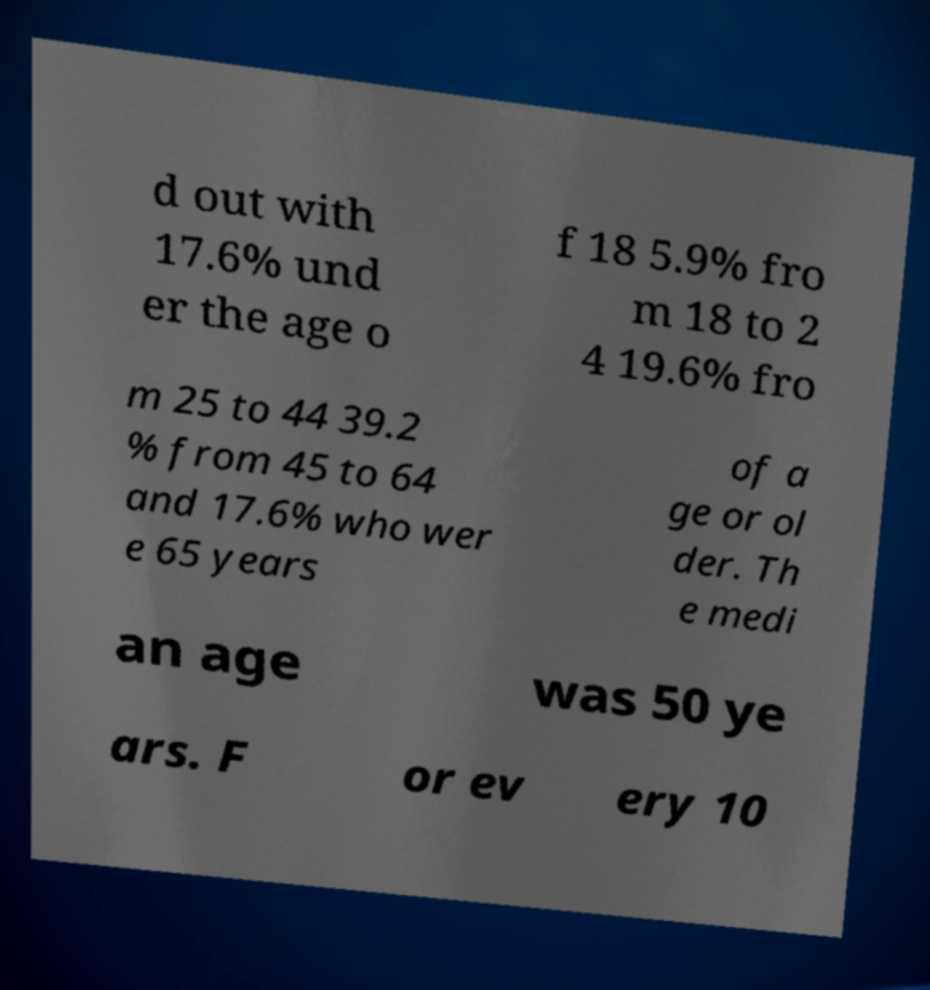Please read and relay the text visible in this image. What does it say? d out with 17.6% und er the age o f 18 5.9% fro m 18 to 2 4 19.6% fro m 25 to 44 39.2 % from 45 to 64 and 17.6% who wer e 65 years of a ge or ol der. Th e medi an age was 50 ye ars. F or ev ery 10 